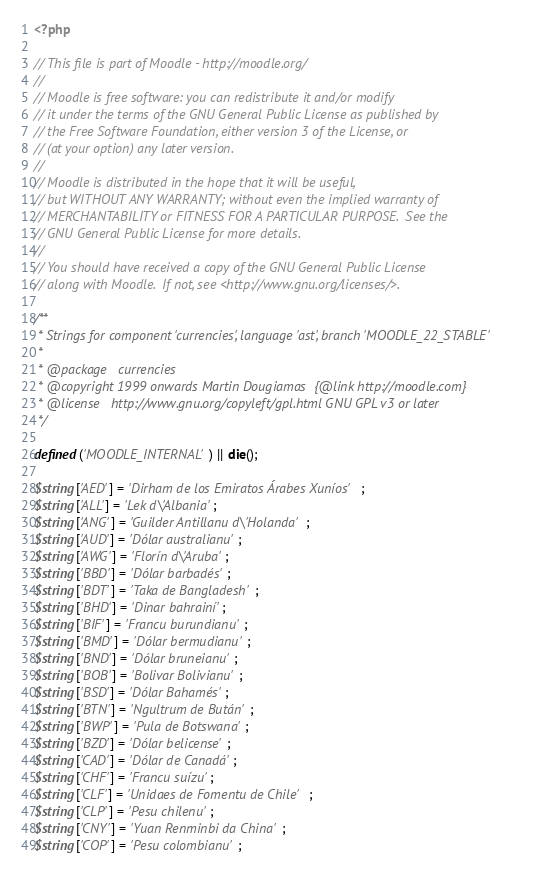<code> <loc_0><loc_0><loc_500><loc_500><_PHP_><?php

// This file is part of Moodle - http://moodle.org/
//
// Moodle is free software: you can redistribute it and/or modify
// it under the terms of the GNU General Public License as published by
// the Free Software Foundation, either version 3 of the License, or
// (at your option) any later version.
//
// Moodle is distributed in the hope that it will be useful,
// but WITHOUT ANY WARRANTY; without even the implied warranty of
// MERCHANTABILITY or FITNESS FOR A PARTICULAR PURPOSE.  See the
// GNU General Public License for more details.
//
// You should have received a copy of the GNU General Public License
// along with Moodle.  If not, see <http://www.gnu.org/licenses/>.

/**
 * Strings for component 'currencies', language 'ast', branch 'MOODLE_22_STABLE'
 *
 * @package   currencies
 * @copyright 1999 onwards Martin Dougiamas  {@link http://moodle.com}
 * @license   http://www.gnu.org/copyleft/gpl.html GNU GPL v3 or later
 */

defined('MOODLE_INTERNAL') || die();

$string['AED'] = 'Dirham de los Emiratos Árabes Xuníos';
$string['ALL'] = 'Lek d\'Albania';
$string['ANG'] = 'Guilder Antillanu d\'Holanda';
$string['AUD'] = 'Dólar australianu';
$string['AWG'] = 'Florín d\'Aruba';
$string['BBD'] = 'Dólar barbadés';
$string['BDT'] = 'Taka de Bangladesh';
$string['BHD'] = 'Dinar bahrainí';
$string['BIF'] = 'Francu burundianu';
$string['BMD'] = 'Dólar bermudianu';
$string['BND'] = 'Dólar bruneianu';
$string['BOB'] = 'Bolivar Bolivianu';
$string['BSD'] = 'Dólar Bahamés';
$string['BTN'] = 'Ngultrum de Bután';
$string['BWP'] = 'Pula de Botswana';
$string['BZD'] = 'Dólar belicense';
$string['CAD'] = 'Dólar de Canadá';
$string['CHF'] = 'Francu suízu';
$string['CLF'] = 'Unidaes de Fomentu de Chile';
$string['CLP'] = 'Pesu chilenu';
$string['CNY'] = 'Yuan Renminbi da China';
$string['COP'] = 'Pesu colombianu';</code> 